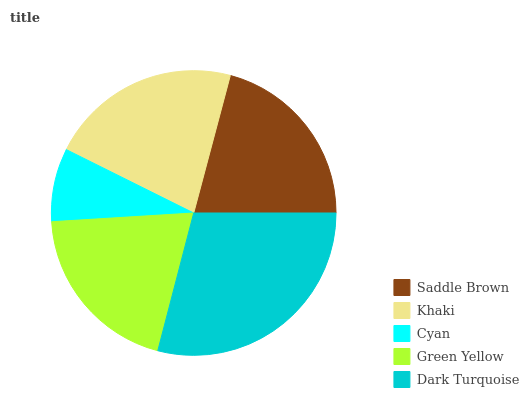Is Cyan the minimum?
Answer yes or no. Yes. Is Dark Turquoise the maximum?
Answer yes or no. Yes. Is Khaki the minimum?
Answer yes or no. No. Is Khaki the maximum?
Answer yes or no. No. Is Khaki greater than Saddle Brown?
Answer yes or no. Yes. Is Saddle Brown less than Khaki?
Answer yes or no. Yes. Is Saddle Brown greater than Khaki?
Answer yes or no. No. Is Khaki less than Saddle Brown?
Answer yes or no. No. Is Saddle Brown the high median?
Answer yes or no. Yes. Is Saddle Brown the low median?
Answer yes or no. Yes. Is Green Yellow the high median?
Answer yes or no. No. Is Khaki the low median?
Answer yes or no. No. 